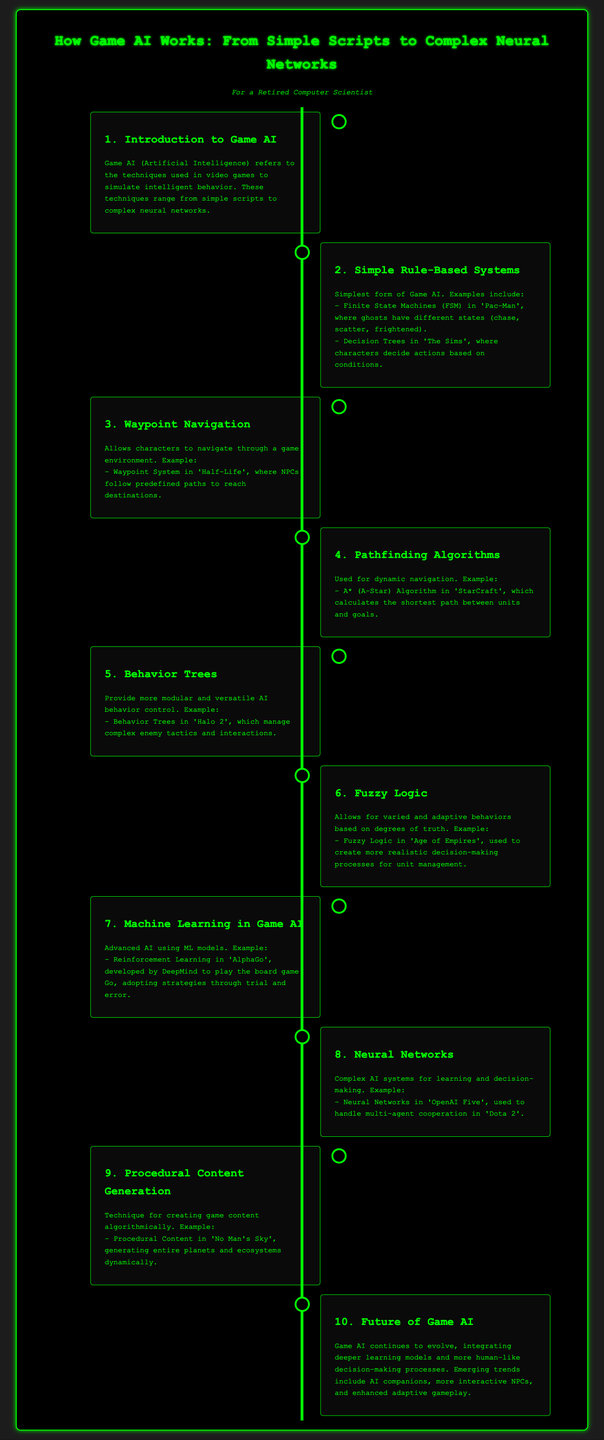What is the first topic discussed in the infographic? The first topic mentioned in the infographic introduces Game AI and its importance in simulating intelligent behavior.
Answer: Introduction to Game AI Which game features Finite State Machines? The example given for Finite State Machines is 'Pac-Man', where ghosts have different states.
Answer: Pac-Man What algorithm is used for dynamic navigation in 'StarCraft'? The infographic specifies the A* (A-Star) Algorithm for pathfinding in 'StarCraft'.
Answer: A* (A-Star) Algorithm What example demonstrates Procedural Content Generation? 'No Man's Sky' is cited as an example of Procedural Content Generation in the document.
Answer: No Man's Sky What AI technique is used in 'AlphaGo'? Reinforcement Learning is the advanced AI technique mentioned for 'AlphaGo'.
Answer: Reinforcement Learning Which section discusses more human-like decision-making? The Future of Game AI section covers advances in integrating deeper learning models for more human-like decision-making processes.
Answer: Future of Game AI How does Fuzzy Logic enhance unit management? The description mentions that it allows more realistic decision-making processes in 'Age of Empires'.
Answer: Age of Empires What is the last topic presented in the timeline? The last topic discussed in the infographic is the Future of Game AI, which covers emerging trends.
Answer: Future of Game AI Which game demonstrates the use of Neural Networks? The document cites 'OpenAI Five' in 'Dota 2' as an example of Neural Networks.
Answer: OpenAI Five 